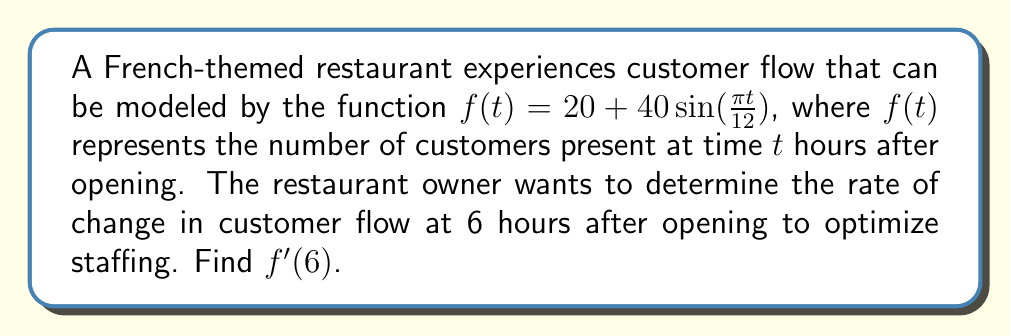Solve this math problem. To find the rate of change in customer flow at 6 hours after opening, we need to calculate $f'(6)$. Let's approach this step-by-step:

1) First, we need to find the derivative of $f(t)$:
   $f(t) = 20 + 40\sin(\frac{\pi t}{12})$
   
   Using the chain rule, we get:
   $f'(t) = 40 \cdot \cos(\frac{\pi t}{12}) \cdot \frac{\pi}{12}$
   
   Simplifying:
   $f'(t) = \frac{10\pi}{3} \cos(\frac{\pi t}{12})$

2) Now that we have $f'(t)$, we can find $f'(6)$ by substituting $t=6$:

   $f'(6) = \frac{10\pi}{3} \cos(\frac{\pi \cdot 6}{12})$
   
   $= \frac{10\pi}{3} \cos(\frac{\pi}{2})$

3) We know that $\cos(\frac{\pi}{2}) = 0$, so:

   $f'(6) = \frac{10\pi}{3} \cdot 0 = 0$

Therefore, the rate of change in customer flow at 6 hours after opening is 0 customers per hour.
Answer: $0$ customers/hour 